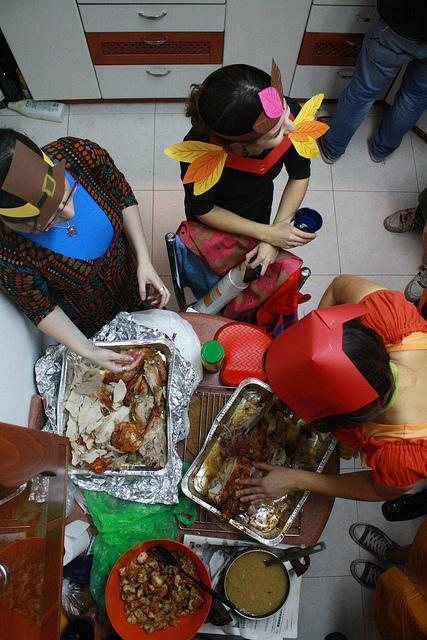What holiday do the people seem to be celebrating? Please explain your reasoning. thanksgiving. The holiday is thanksgiving. 